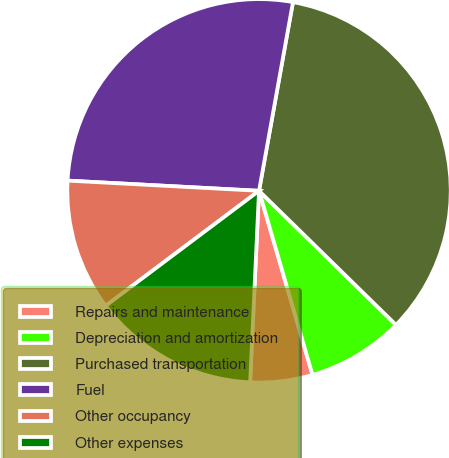Convert chart. <chart><loc_0><loc_0><loc_500><loc_500><pie_chart><fcel>Repairs and maintenance<fcel>Depreciation and amortization<fcel>Purchased transportation<fcel>Fuel<fcel>Other occupancy<fcel>Other expenses<nl><fcel>5.24%<fcel>8.17%<fcel>34.5%<fcel>26.99%<fcel>11.09%<fcel>14.02%<nl></chart> 